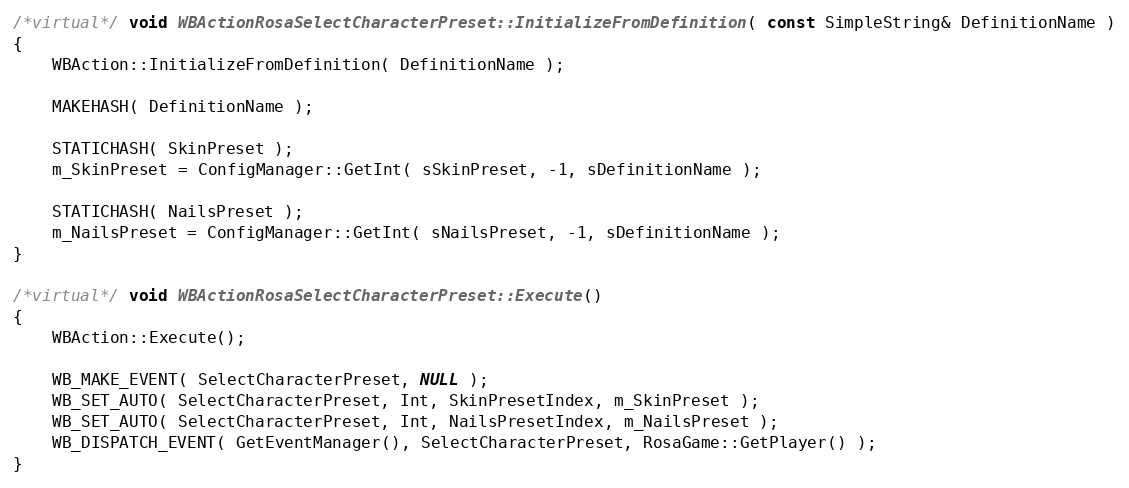<code> <loc_0><loc_0><loc_500><loc_500><_C++_>
/*virtual*/ void WBActionRosaSelectCharacterPreset::InitializeFromDefinition( const SimpleString& DefinitionName )
{
	WBAction::InitializeFromDefinition( DefinitionName );

	MAKEHASH( DefinitionName );

	STATICHASH( SkinPreset );
	m_SkinPreset = ConfigManager::GetInt( sSkinPreset, -1, sDefinitionName );

	STATICHASH( NailsPreset );
	m_NailsPreset = ConfigManager::GetInt( sNailsPreset, -1, sDefinitionName );
}

/*virtual*/ void WBActionRosaSelectCharacterPreset::Execute()
{
	WBAction::Execute();

	WB_MAKE_EVENT( SelectCharacterPreset, NULL );
	WB_SET_AUTO( SelectCharacterPreset, Int, SkinPresetIndex, m_SkinPreset );
	WB_SET_AUTO( SelectCharacterPreset, Int, NailsPresetIndex, m_NailsPreset );
	WB_DISPATCH_EVENT( GetEventManager(), SelectCharacterPreset, RosaGame::GetPlayer() );
}
</code> 